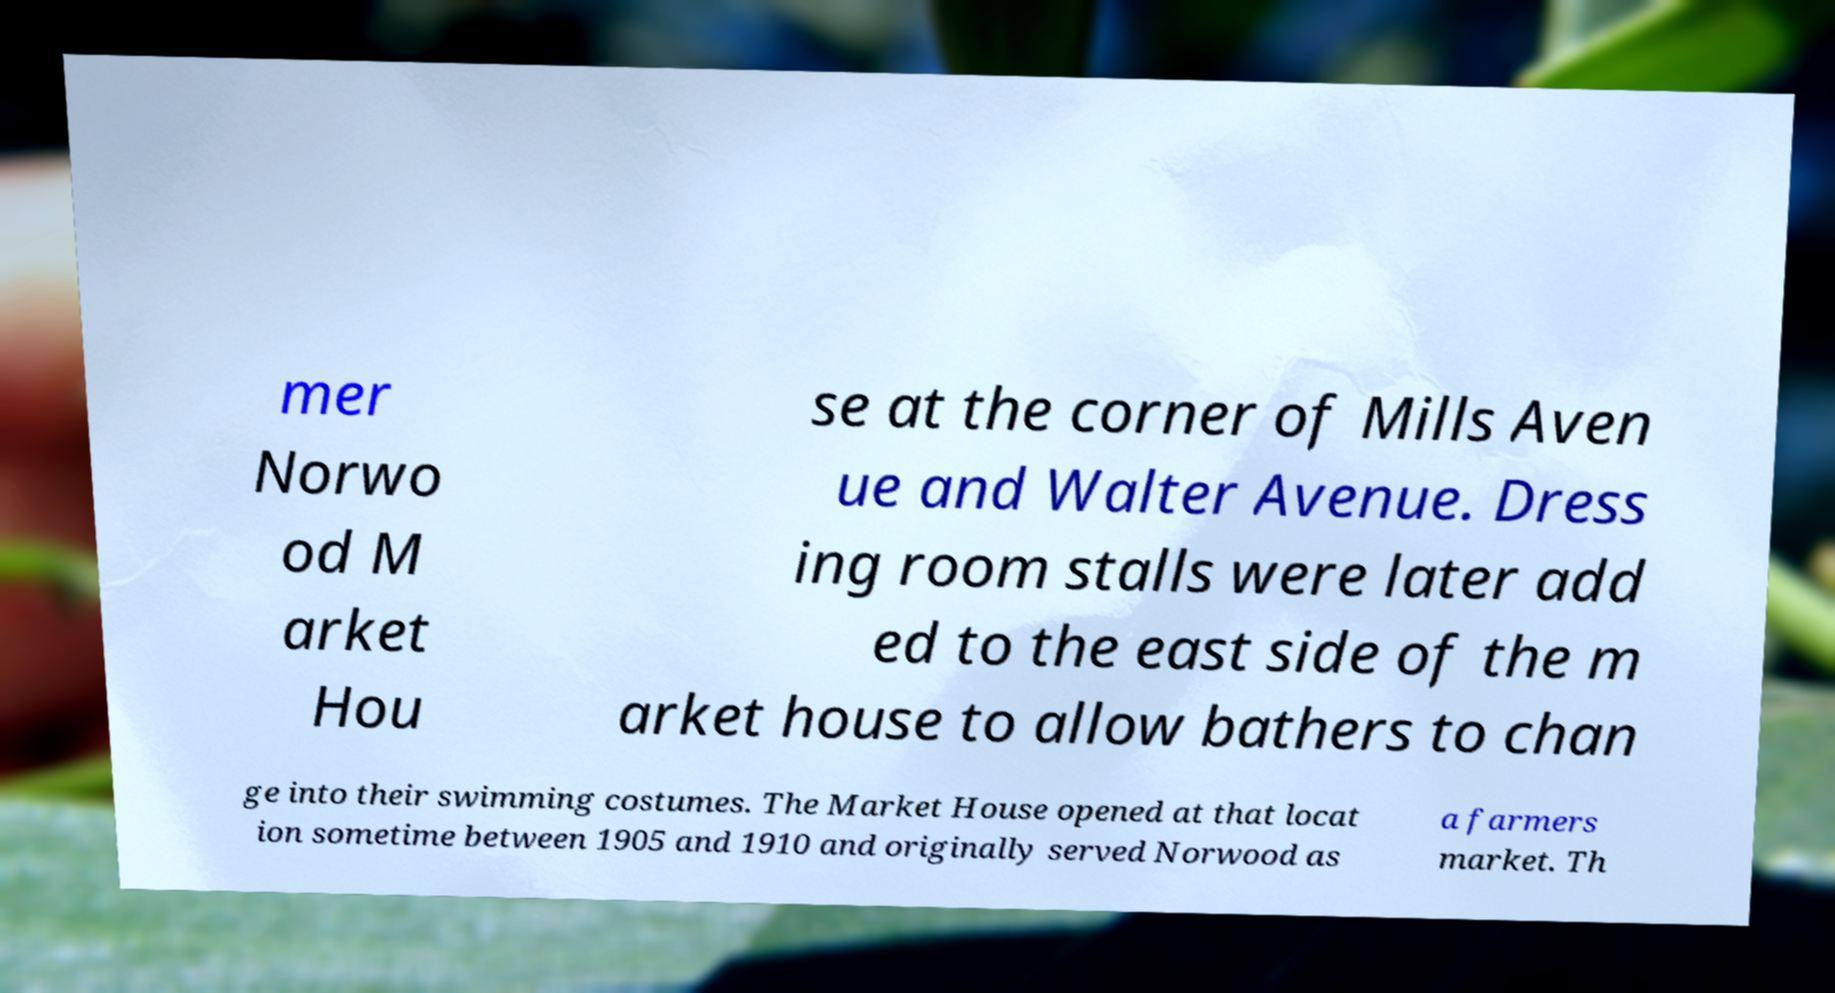Please read and relay the text visible in this image. What does it say? mer Norwo od M arket Hou se at the corner of Mills Aven ue and Walter Avenue. Dress ing room stalls were later add ed to the east side of the m arket house to allow bathers to chan ge into their swimming costumes. The Market House opened at that locat ion sometime between 1905 and 1910 and originally served Norwood as a farmers market. Th 